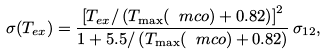<formula> <loc_0><loc_0><loc_500><loc_500>\sigma ( T _ { e x } ) = \frac { \left [ T _ { e x } / \left ( T _ { \max } ( \ m c o ) + 0 . 8 2 \right ) \right ] ^ { 2 } } { 1 + 5 . 5 / \left ( T _ { \max } ( \ m c o ) + 0 . 8 2 \right ) } \, \sigma _ { 1 2 } ,</formula> 